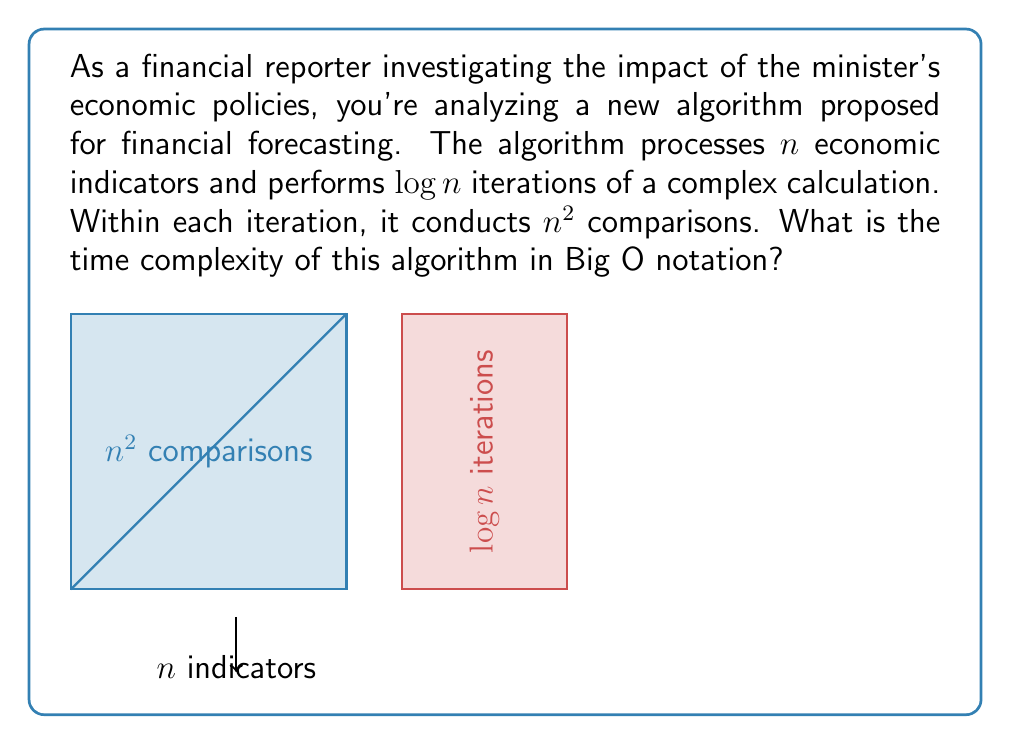Solve this math problem. To determine the time complexity, we need to analyze the structure of the algorithm:

1) The algorithm processes $n$ economic indicators.

2) It performs $\log n$ iterations.

3) Within each iteration, it conducts $n^2$ comparisons.

Let's break down the complexity:

a) The $n^2$ comparisons are nested within the $\log n$ iterations.
   This means we multiply these components: $\log n \cdot n^2$

b) The time complexity is thus:
   $T(n) = \log n \cdot n^2$

c) In Big O notation, we simplify this to:
   $O(\log n \cdot n^2)$

d) We can further simplify this:
   $O(n^2 \log n)$

This is because $n^2$ grows faster than $\log n$, but we keep the $\log n$ term as it's still significant compared to $n^2$.
Answer: $O(n^2 \log n)$ 